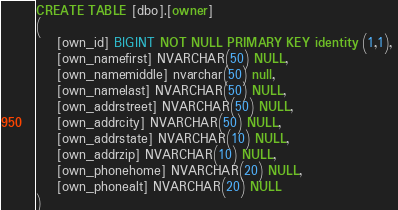Convert code to text. <code><loc_0><loc_0><loc_500><loc_500><_SQL_>CREATE TABLE [dbo].[owner]
(
    [own_id] BIGINT NOT NULL PRIMARY KEY identity (1,1), 
    [own_namefirst] NVARCHAR(50) NULL, 
    [own_namemiddle] nvarchar(50) null,
    [own_namelast] NVARCHAR(50) NULL,
    [own_addrstreet] NVARCHAR(50) NULL, 
    [own_addrcity] NVARCHAR(50) NULL, 
    [own_addrstate] NVARCHAR(10) NULL, 
    [own_addrzip] NVARCHAR(10) NULL, 
    [own_phonehome] NVARCHAR(20) NULL, 
    [own_phonealt] NVARCHAR(20) NULL
)
</code> 